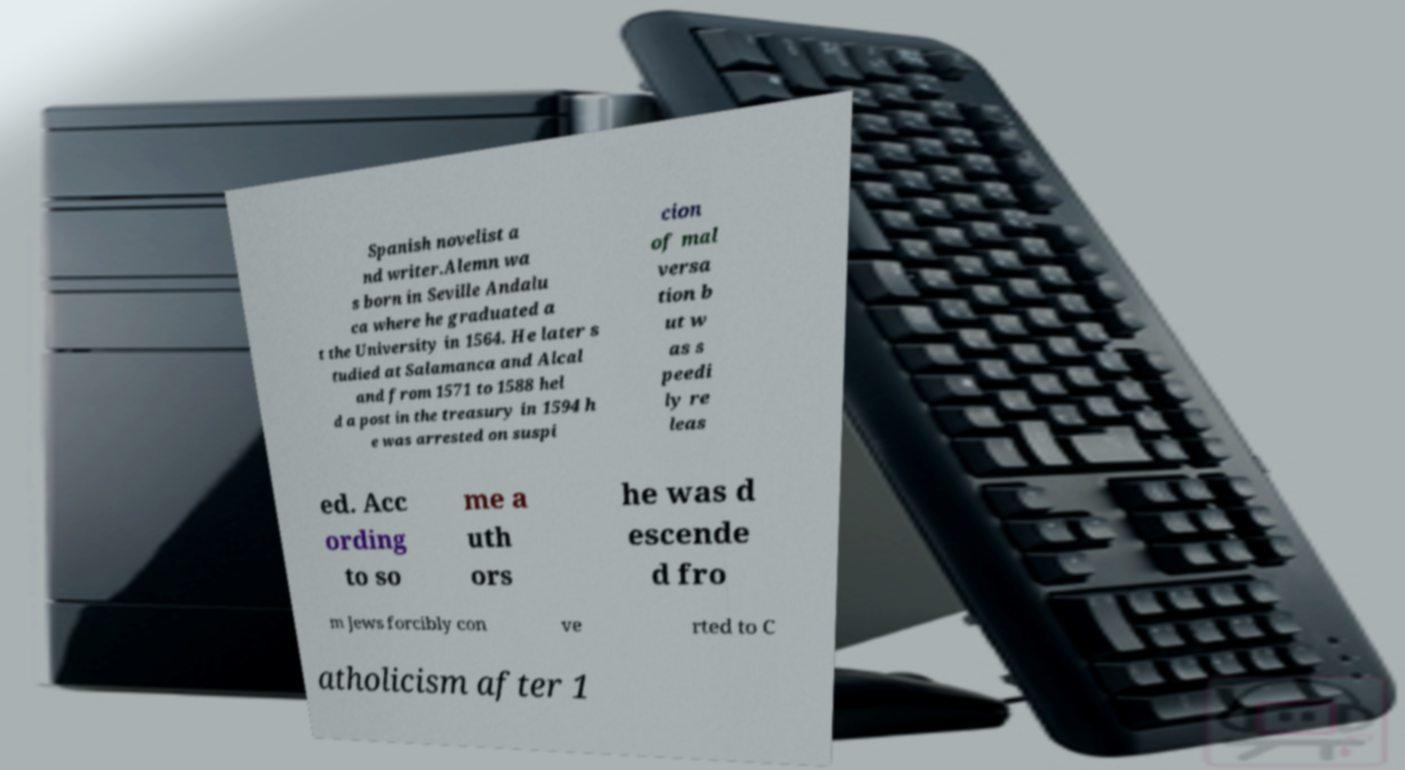Can you accurately transcribe the text from the provided image for me? Spanish novelist a nd writer.Alemn wa s born in Seville Andalu ca where he graduated a t the University in 1564. He later s tudied at Salamanca and Alcal and from 1571 to 1588 hel d a post in the treasury in 1594 h e was arrested on suspi cion of mal versa tion b ut w as s peedi ly re leas ed. Acc ording to so me a uth ors he was d escende d fro m Jews forcibly con ve rted to C atholicism after 1 